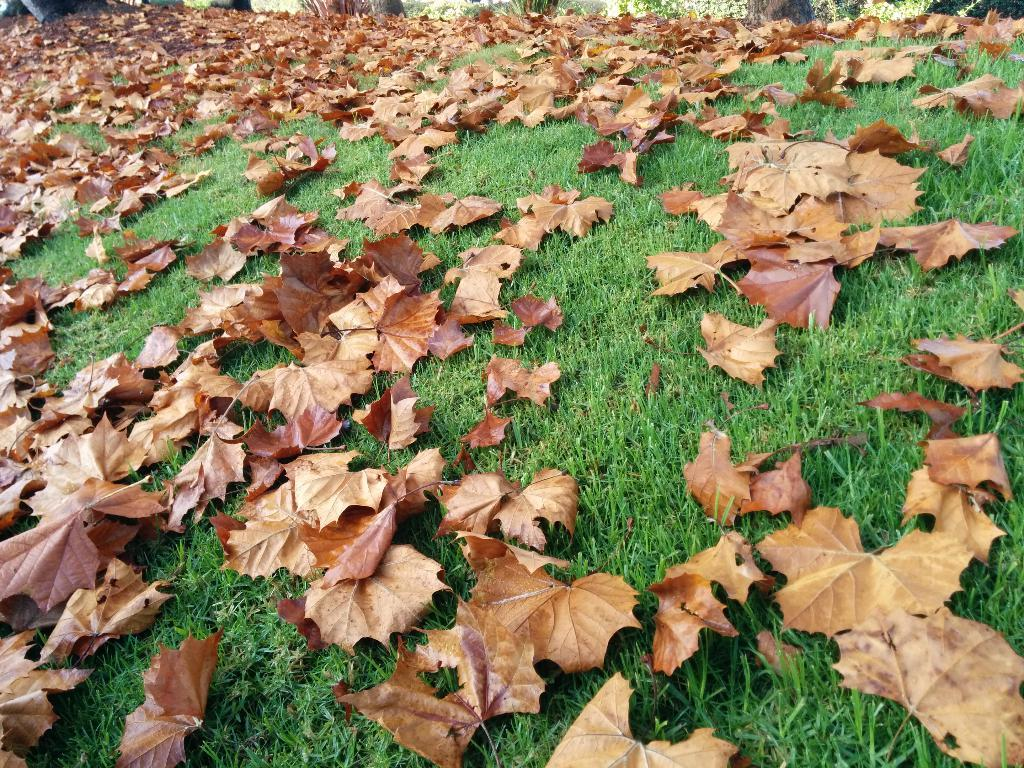What is covering the ground in the image? There are many dry leaves on the ground. What type of vegetation is present on the ground? The ground is full of grass. How does the fog affect the visibility of the light in the image? There is no fog or light present in the image; it only features dry leaves and grass on the ground. 